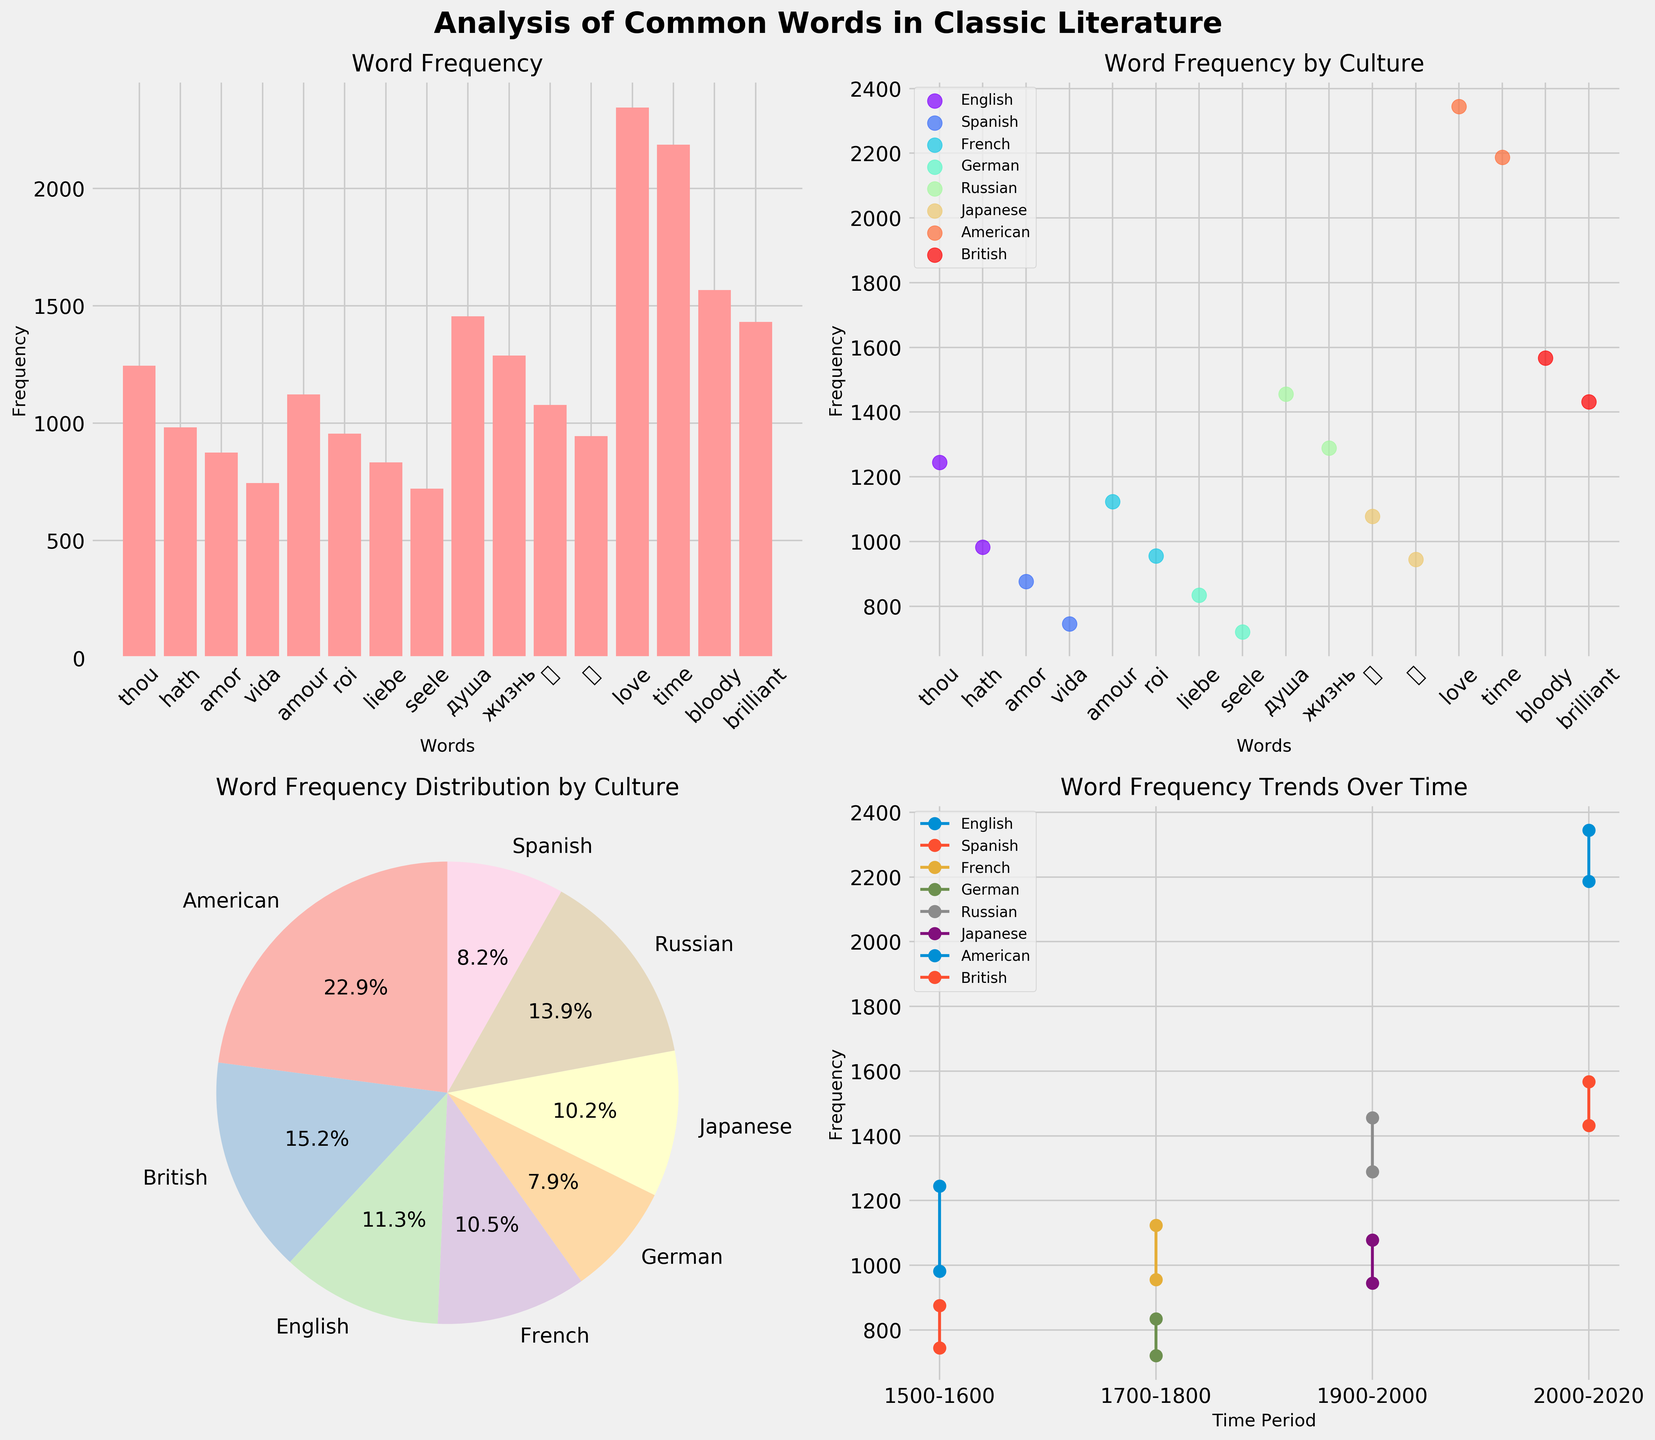What is the title of the figure? The title is usually located at the top of the figure. In this case, it is 'Analysis of Common Words in Classic Literature'.
Answer: Analysis of Common Words in Classic Literature How many subplots are in the figure? The layout of the subplots can be inferred from the arrangement in the figure. There are four subplots arranged in a 2x2 grid.
Answer: 4 Which word has the highest frequency in the "Word Frequency" bar plot? By looking at the heights of the bars in the bar plot, the word with the highest bar is 'love'.
Answer: love What are the top two words by frequency in the "Word Frequency by Culture" scatter plot? The scatter plot shows different cultures with different colors. Identify the highest two points. The word 'love' and 'time' have the highest frequencies.
Answer: love, time Which culture has the highest total word frequency in the pie chart? In the pie chart, the largest slice indicates the culture with the highest total word frequency. The 'American' culture slice is the largest.
Answer: American What trend is observed in the frequencies of English words over time in the line plot? The line plot shows word frequencies over different time periods. Observing the English line, it starts high in the 1500-1600 period and is not present in later periods, indicating a downward trend.
Answer: Downward trend Compare the frequencies of 'amor' and 'amour' in the scatter plot. Which one is higher? Locate 'amor' and 'amour' points in the scatter plot. 'Amour' has a higher frequency than 'amor'.
Answer: amour What percentage of the total word frequency is contributed by the Russian culture according to the pie chart? Check the percentage labeled on the Russian culture slice in the pie chart. It is approximately 13.4%.
Answer: 13.4% Which time period shows the highest frequency of words in the line plot? In the line plot, the highest point across all cultures and periods is around the 2000-2020 period with American culture having a word frequency peaking at 2345.
Answer: 2000-2020 Which two cultures have the closest total word frequencies according to the pie chart? Comprehend the distances between slices in the pie chart. The British and German cultures have close total word frequencies.
Answer: British, German 